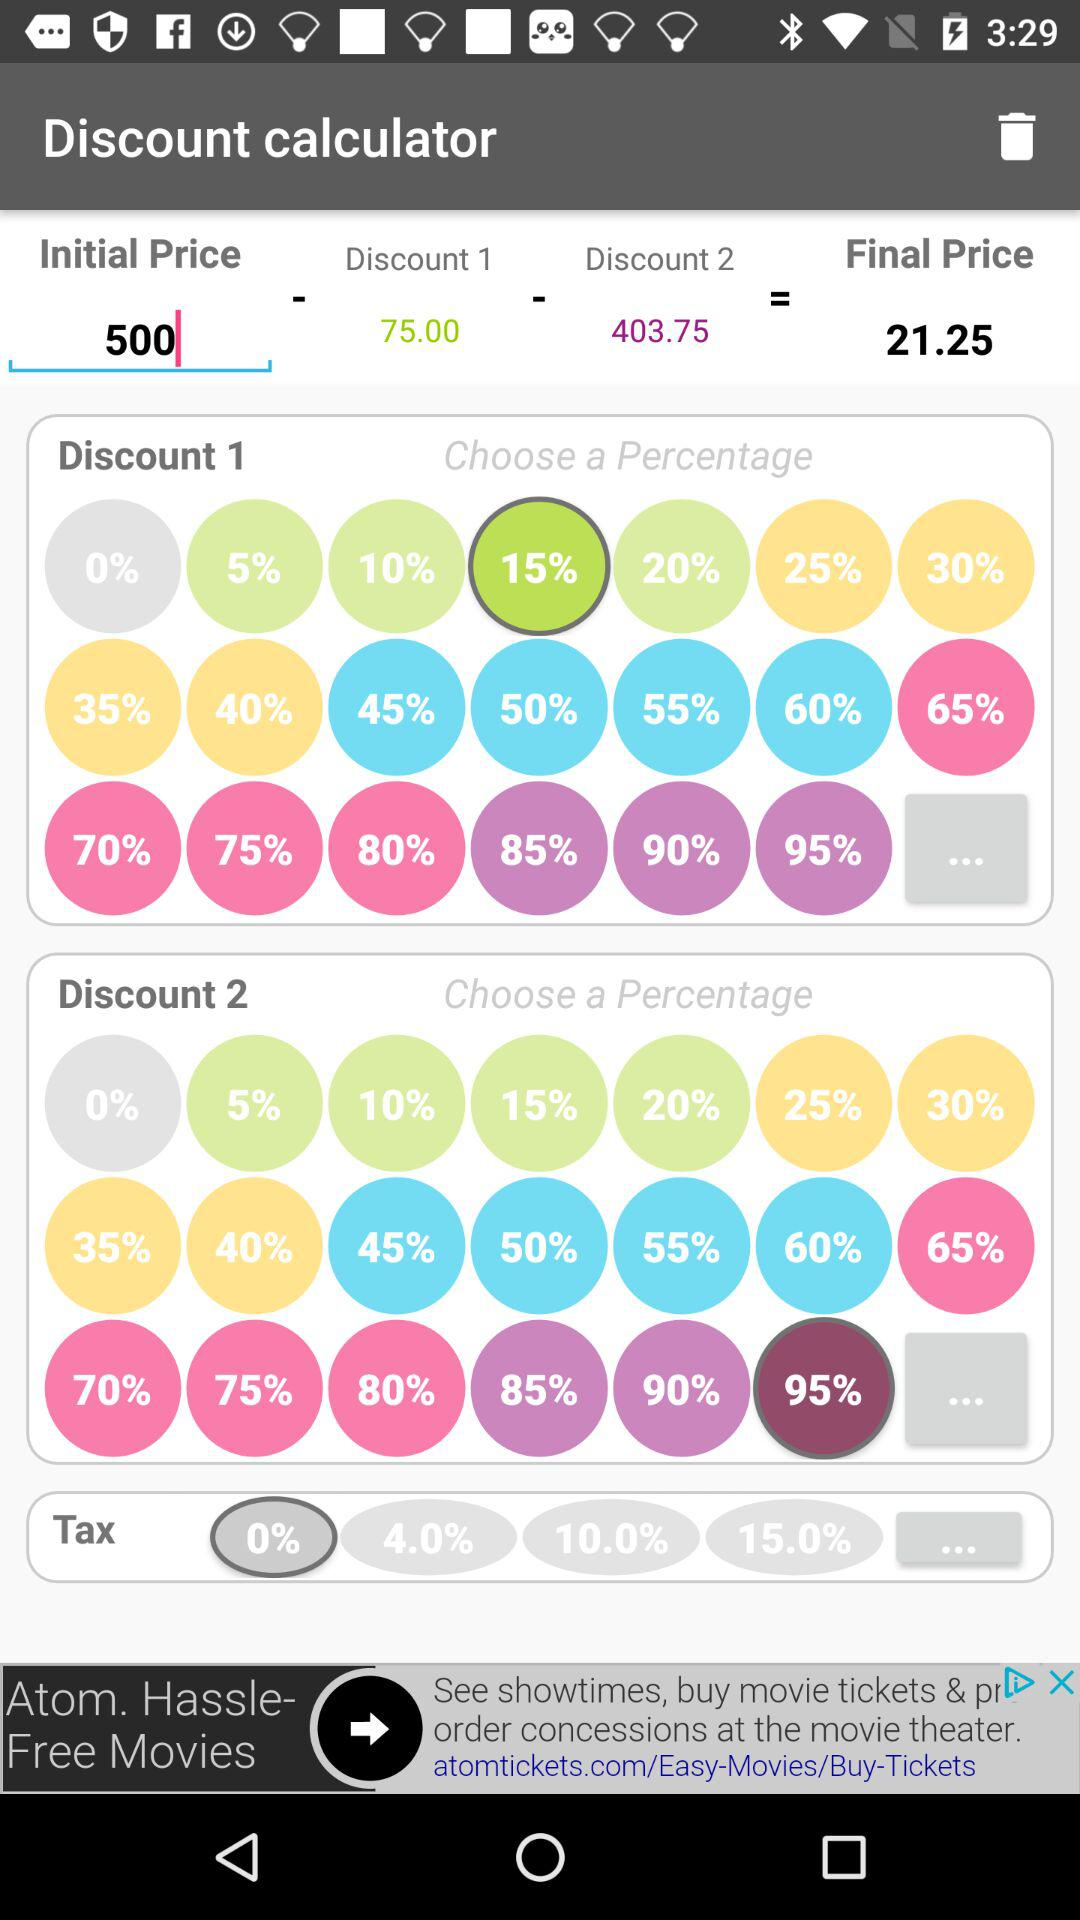What is the final price? The final price is 21.25. 